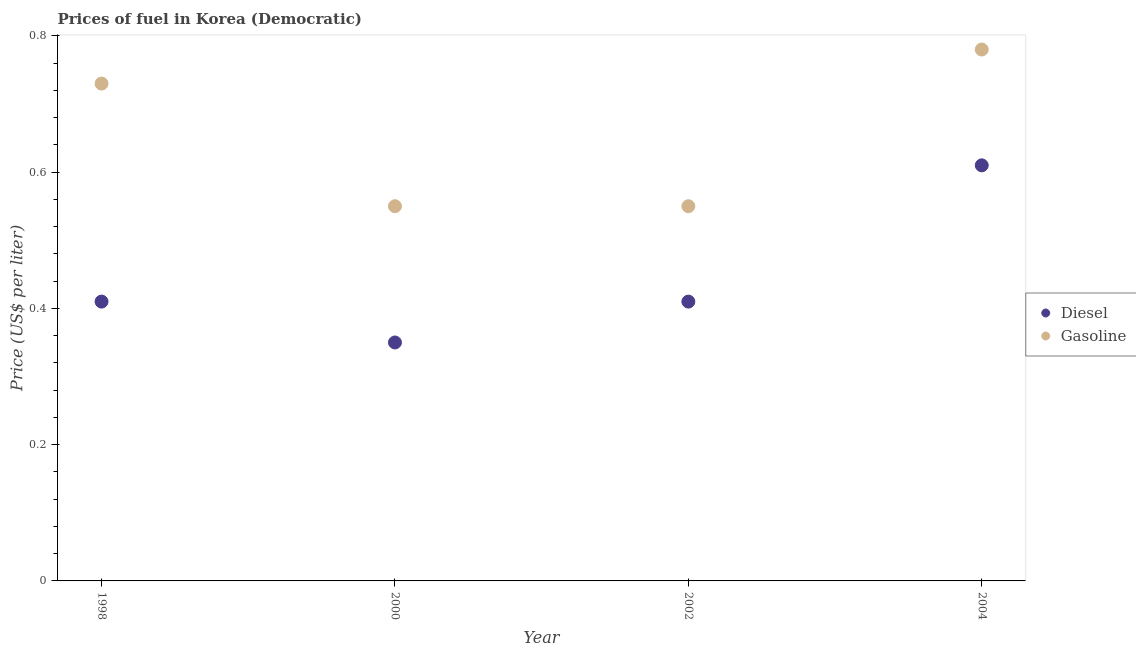How many different coloured dotlines are there?
Your answer should be compact. 2. What is the diesel price in 2002?
Your response must be concise. 0.41. Across all years, what is the maximum diesel price?
Offer a very short reply. 0.61. Across all years, what is the minimum gasoline price?
Offer a terse response. 0.55. In which year was the diesel price maximum?
Provide a short and direct response. 2004. In which year was the gasoline price minimum?
Your answer should be very brief. 2000. What is the total diesel price in the graph?
Provide a short and direct response. 1.78. What is the difference between the diesel price in 1998 and that in 2000?
Offer a very short reply. 0.06. What is the difference between the gasoline price in 2002 and the diesel price in 2000?
Keep it short and to the point. 0.2. What is the average diesel price per year?
Keep it short and to the point. 0.44. In the year 1998, what is the difference between the gasoline price and diesel price?
Keep it short and to the point. 0.32. In how many years, is the diesel price greater than 0.36 US$ per litre?
Provide a succinct answer. 3. What is the ratio of the gasoline price in 1998 to that in 2004?
Make the answer very short. 0.94. Is the gasoline price in 1998 less than that in 2000?
Offer a terse response. No. What is the difference between the highest and the second highest gasoline price?
Give a very brief answer. 0.05. What is the difference between the highest and the lowest diesel price?
Your answer should be compact. 0.26. Is the sum of the gasoline price in 1998 and 2004 greater than the maximum diesel price across all years?
Offer a terse response. Yes. Is the diesel price strictly greater than the gasoline price over the years?
Your response must be concise. No. How many years are there in the graph?
Your response must be concise. 4. What is the difference between two consecutive major ticks on the Y-axis?
Make the answer very short. 0.2. Does the graph contain any zero values?
Offer a very short reply. No. Does the graph contain grids?
Offer a very short reply. No. Where does the legend appear in the graph?
Make the answer very short. Center right. How many legend labels are there?
Your answer should be very brief. 2. What is the title of the graph?
Your answer should be very brief. Prices of fuel in Korea (Democratic). What is the label or title of the X-axis?
Offer a terse response. Year. What is the label or title of the Y-axis?
Offer a very short reply. Price (US$ per liter). What is the Price (US$ per liter) of Diesel in 1998?
Ensure brevity in your answer.  0.41. What is the Price (US$ per liter) in Gasoline in 1998?
Give a very brief answer. 0.73. What is the Price (US$ per liter) of Gasoline in 2000?
Offer a very short reply. 0.55. What is the Price (US$ per liter) of Diesel in 2002?
Make the answer very short. 0.41. What is the Price (US$ per liter) in Gasoline in 2002?
Your answer should be compact. 0.55. What is the Price (US$ per liter) of Diesel in 2004?
Your answer should be very brief. 0.61. What is the Price (US$ per liter) in Gasoline in 2004?
Offer a terse response. 0.78. Across all years, what is the maximum Price (US$ per liter) in Diesel?
Make the answer very short. 0.61. Across all years, what is the maximum Price (US$ per liter) in Gasoline?
Provide a short and direct response. 0.78. Across all years, what is the minimum Price (US$ per liter) in Gasoline?
Provide a short and direct response. 0.55. What is the total Price (US$ per liter) of Diesel in the graph?
Provide a succinct answer. 1.78. What is the total Price (US$ per liter) in Gasoline in the graph?
Offer a terse response. 2.61. What is the difference between the Price (US$ per liter) of Gasoline in 1998 and that in 2000?
Offer a terse response. 0.18. What is the difference between the Price (US$ per liter) of Gasoline in 1998 and that in 2002?
Offer a very short reply. 0.18. What is the difference between the Price (US$ per liter) of Diesel in 1998 and that in 2004?
Ensure brevity in your answer.  -0.2. What is the difference between the Price (US$ per liter) in Gasoline in 1998 and that in 2004?
Give a very brief answer. -0.05. What is the difference between the Price (US$ per liter) of Diesel in 2000 and that in 2002?
Make the answer very short. -0.06. What is the difference between the Price (US$ per liter) in Gasoline in 2000 and that in 2002?
Your response must be concise. 0. What is the difference between the Price (US$ per liter) of Diesel in 2000 and that in 2004?
Make the answer very short. -0.26. What is the difference between the Price (US$ per liter) of Gasoline in 2000 and that in 2004?
Ensure brevity in your answer.  -0.23. What is the difference between the Price (US$ per liter) of Diesel in 2002 and that in 2004?
Make the answer very short. -0.2. What is the difference between the Price (US$ per liter) in Gasoline in 2002 and that in 2004?
Offer a terse response. -0.23. What is the difference between the Price (US$ per liter) of Diesel in 1998 and the Price (US$ per liter) of Gasoline in 2000?
Provide a short and direct response. -0.14. What is the difference between the Price (US$ per liter) in Diesel in 1998 and the Price (US$ per liter) in Gasoline in 2002?
Keep it short and to the point. -0.14. What is the difference between the Price (US$ per liter) in Diesel in 1998 and the Price (US$ per liter) in Gasoline in 2004?
Make the answer very short. -0.37. What is the difference between the Price (US$ per liter) in Diesel in 2000 and the Price (US$ per liter) in Gasoline in 2004?
Offer a very short reply. -0.43. What is the difference between the Price (US$ per liter) in Diesel in 2002 and the Price (US$ per liter) in Gasoline in 2004?
Your response must be concise. -0.37. What is the average Price (US$ per liter) of Diesel per year?
Your answer should be very brief. 0.45. What is the average Price (US$ per liter) in Gasoline per year?
Offer a very short reply. 0.65. In the year 1998, what is the difference between the Price (US$ per liter) in Diesel and Price (US$ per liter) in Gasoline?
Your response must be concise. -0.32. In the year 2002, what is the difference between the Price (US$ per liter) of Diesel and Price (US$ per liter) of Gasoline?
Your answer should be very brief. -0.14. In the year 2004, what is the difference between the Price (US$ per liter) of Diesel and Price (US$ per liter) of Gasoline?
Provide a succinct answer. -0.17. What is the ratio of the Price (US$ per liter) in Diesel in 1998 to that in 2000?
Make the answer very short. 1.17. What is the ratio of the Price (US$ per liter) of Gasoline in 1998 to that in 2000?
Ensure brevity in your answer.  1.33. What is the ratio of the Price (US$ per liter) of Diesel in 1998 to that in 2002?
Provide a succinct answer. 1. What is the ratio of the Price (US$ per liter) in Gasoline in 1998 to that in 2002?
Provide a short and direct response. 1.33. What is the ratio of the Price (US$ per liter) of Diesel in 1998 to that in 2004?
Offer a terse response. 0.67. What is the ratio of the Price (US$ per liter) in Gasoline in 1998 to that in 2004?
Your response must be concise. 0.94. What is the ratio of the Price (US$ per liter) of Diesel in 2000 to that in 2002?
Provide a succinct answer. 0.85. What is the ratio of the Price (US$ per liter) of Diesel in 2000 to that in 2004?
Ensure brevity in your answer.  0.57. What is the ratio of the Price (US$ per liter) of Gasoline in 2000 to that in 2004?
Your answer should be compact. 0.71. What is the ratio of the Price (US$ per liter) in Diesel in 2002 to that in 2004?
Make the answer very short. 0.67. What is the ratio of the Price (US$ per liter) of Gasoline in 2002 to that in 2004?
Provide a short and direct response. 0.71. What is the difference between the highest and the second highest Price (US$ per liter) of Gasoline?
Your answer should be compact. 0.05. What is the difference between the highest and the lowest Price (US$ per liter) of Diesel?
Ensure brevity in your answer.  0.26. What is the difference between the highest and the lowest Price (US$ per liter) of Gasoline?
Provide a succinct answer. 0.23. 